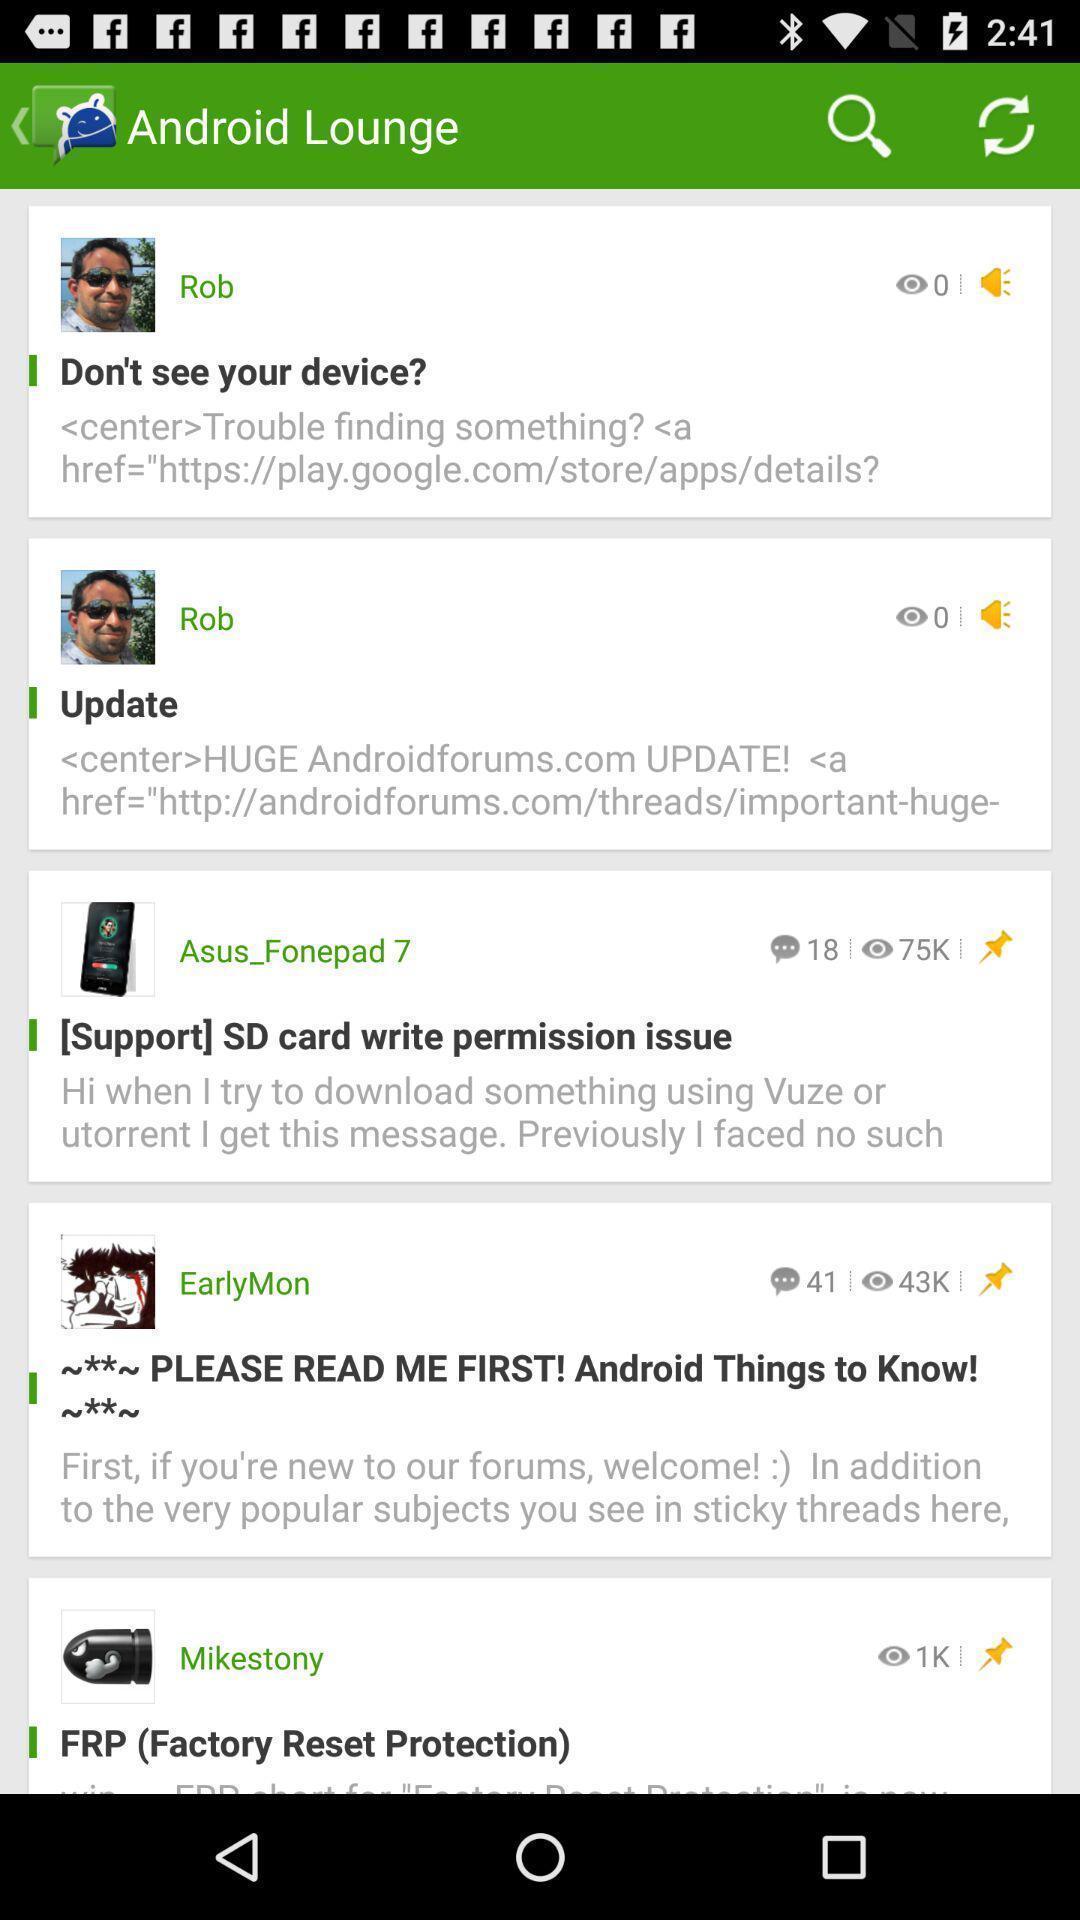Tell me what you see in this picture. Screen showing various comments. 